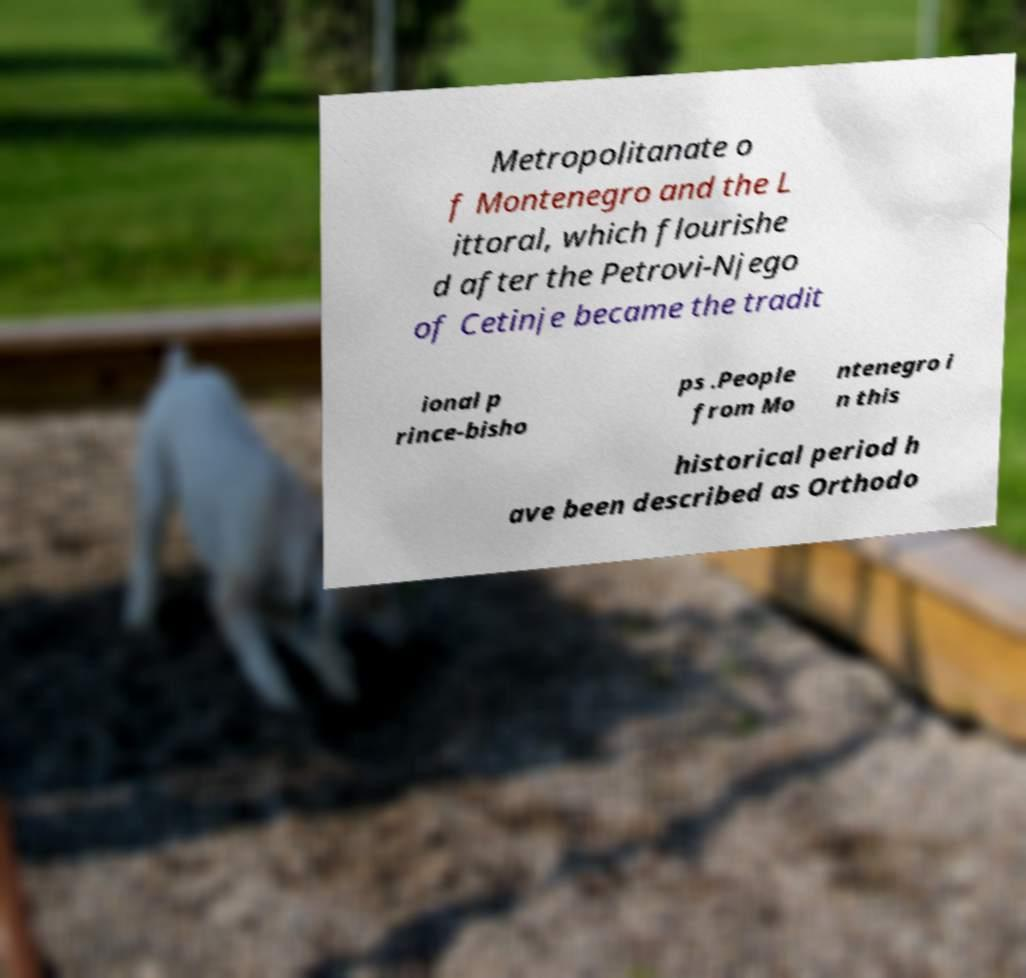Can you accurately transcribe the text from the provided image for me? Metropolitanate o f Montenegro and the L ittoral, which flourishe d after the Petrovi-Njego of Cetinje became the tradit ional p rince-bisho ps .People from Mo ntenegro i n this historical period h ave been described as Orthodo 